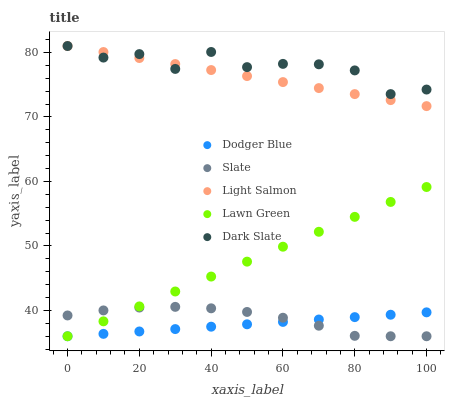Does Dodger Blue have the minimum area under the curve?
Answer yes or no. Yes. Does Dark Slate have the maximum area under the curve?
Answer yes or no. Yes. Does Slate have the minimum area under the curve?
Answer yes or no. No. Does Slate have the maximum area under the curve?
Answer yes or no. No. Is Dodger Blue the smoothest?
Answer yes or no. Yes. Is Dark Slate the roughest?
Answer yes or no. Yes. Is Slate the smoothest?
Answer yes or no. No. Is Slate the roughest?
Answer yes or no. No. Does Lawn Green have the lowest value?
Answer yes or no. Yes. Does Light Salmon have the lowest value?
Answer yes or no. No. Does Dark Slate have the highest value?
Answer yes or no. Yes. Does Slate have the highest value?
Answer yes or no. No. Is Slate less than Dark Slate?
Answer yes or no. Yes. Is Dark Slate greater than Lawn Green?
Answer yes or no. Yes. Does Slate intersect Lawn Green?
Answer yes or no. Yes. Is Slate less than Lawn Green?
Answer yes or no. No. Is Slate greater than Lawn Green?
Answer yes or no. No. Does Slate intersect Dark Slate?
Answer yes or no. No. 